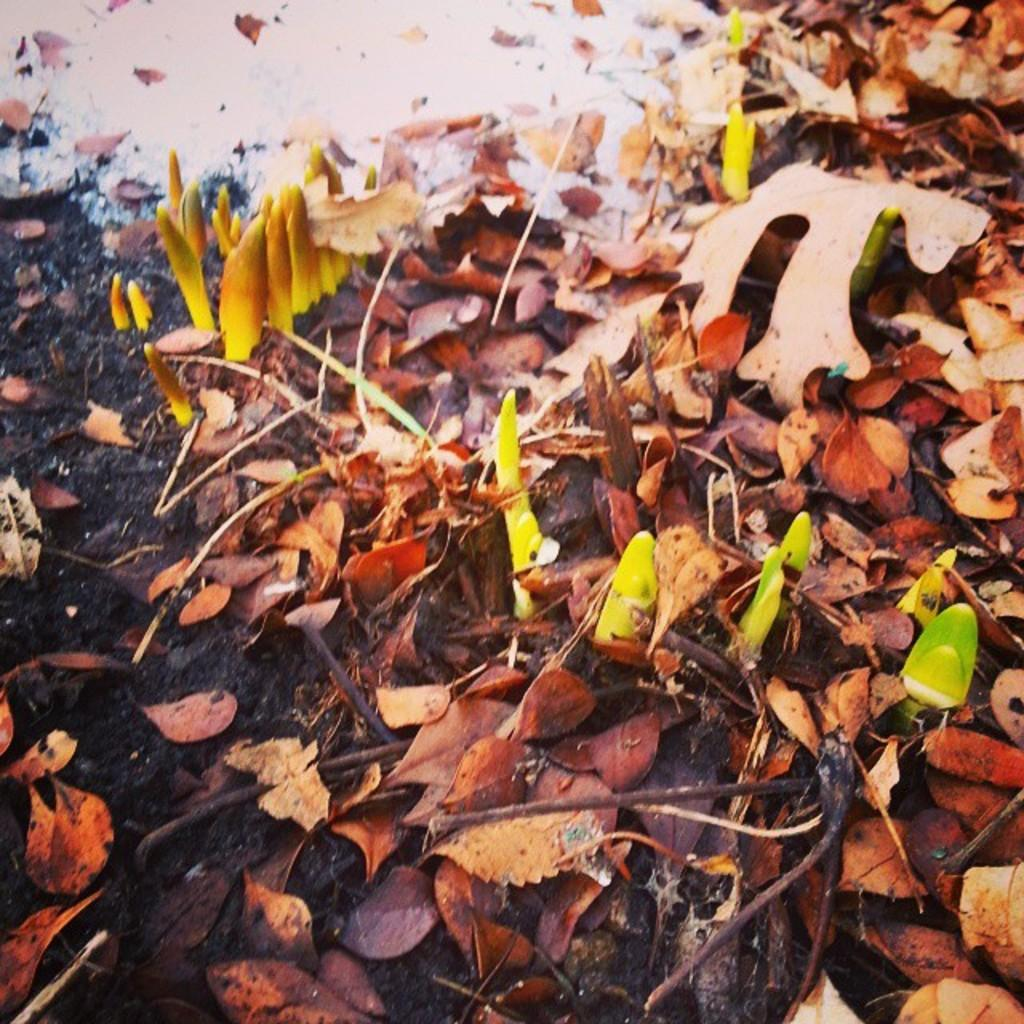What type of natural materials can be seen in the image? The image contains dry leaves, soil, and twigs. Are there any living organisms visible in the image? Yes, small plants are visible in the image. What is the color of the substance at the top of the image? There is a white color substance at the top of the image. What does your mom think about the image? The provided facts do not mention anything about the user's mom, so we cannot answer this question based on the information given. 